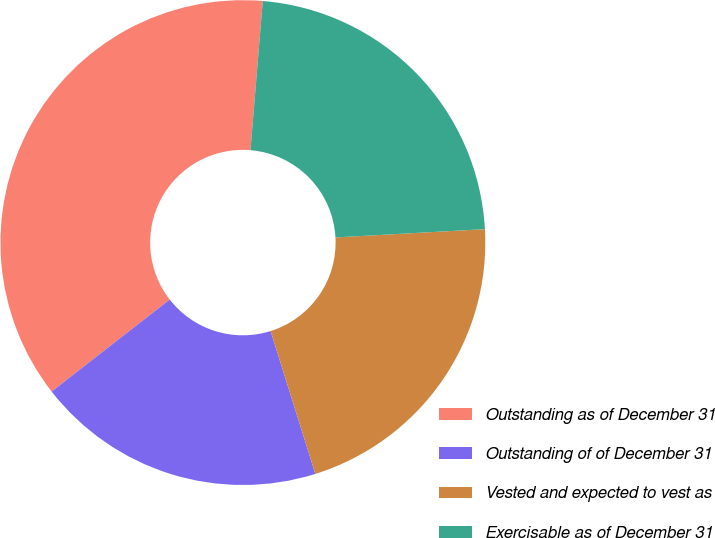<chart> <loc_0><loc_0><loc_500><loc_500><pie_chart><fcel>Outstanding as of December 31<fcel>Outstanding of of December 31<fcel>Vested and expected to vest as<fcel>Exercisable as of December 31<nl><fcel>36.84%<fcel>19.3%<fcel>21.05%<fcel>22.81%<nl></chart> 